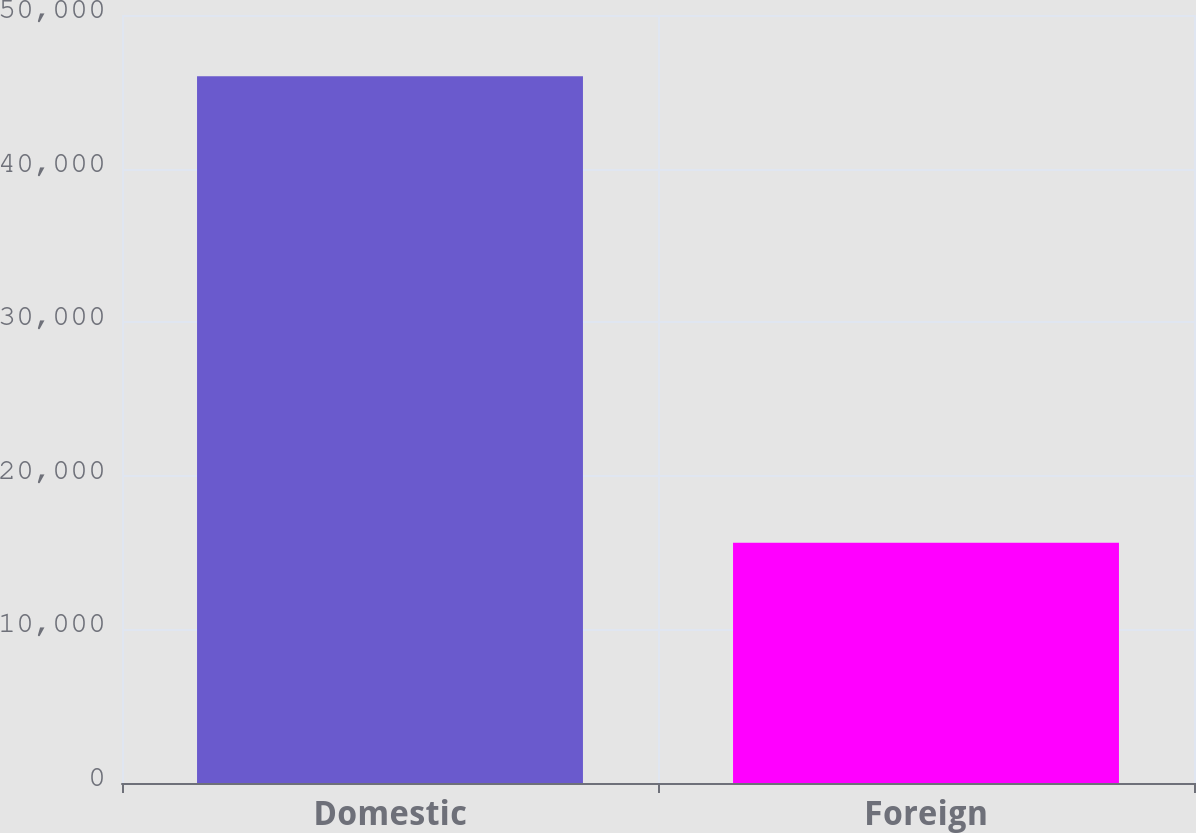Convert chart. <chart><loc_0><loc_0><loc_500><loc_500><bar_chart><fcel>Domestic<fcel>Foreign<nl><fcel>46018<fcel>15643<nl></chart> 